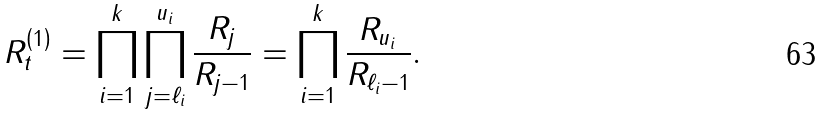Convert formula to latex. <formula><loc_0><loc_0><loc_500><loc_500>R _ { t } ^ { \left ( 1 \right ) } = \prod _ { i = 1 } ^ { k } \prod _ { j = \ell _ { i } } ^ { u _ { i } } \frac { R _ { j } } { R _ { j - 1 } } = \prod _ { i = 1 } ^ { k } \frac { R _ { u _ { i } } } { R _ { \ell _ { i } - 1 } } .</formula> 